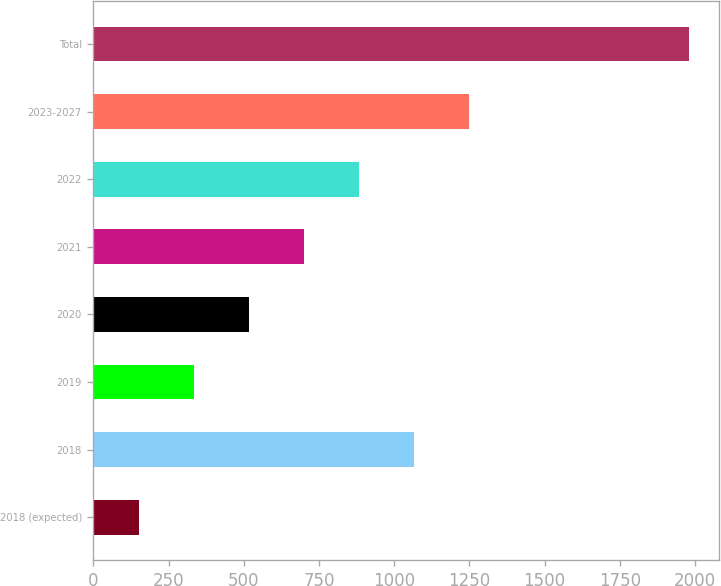Convert chart to OTSL. <chart><loc_0><loc_0><loc_500><loc_500><bar_chart><fcel>2018 (expected)<fcel>2018<fcel>2019<fcel>2020<fcel>2021<fcel>2022<fcel>2023-2027<fcel>Total<nl><fcel>150<fcel>1065<fcel>333<fcel>516<fcel>699<fcel>882<fcel>1248<fcel>1980<nl></chart> 